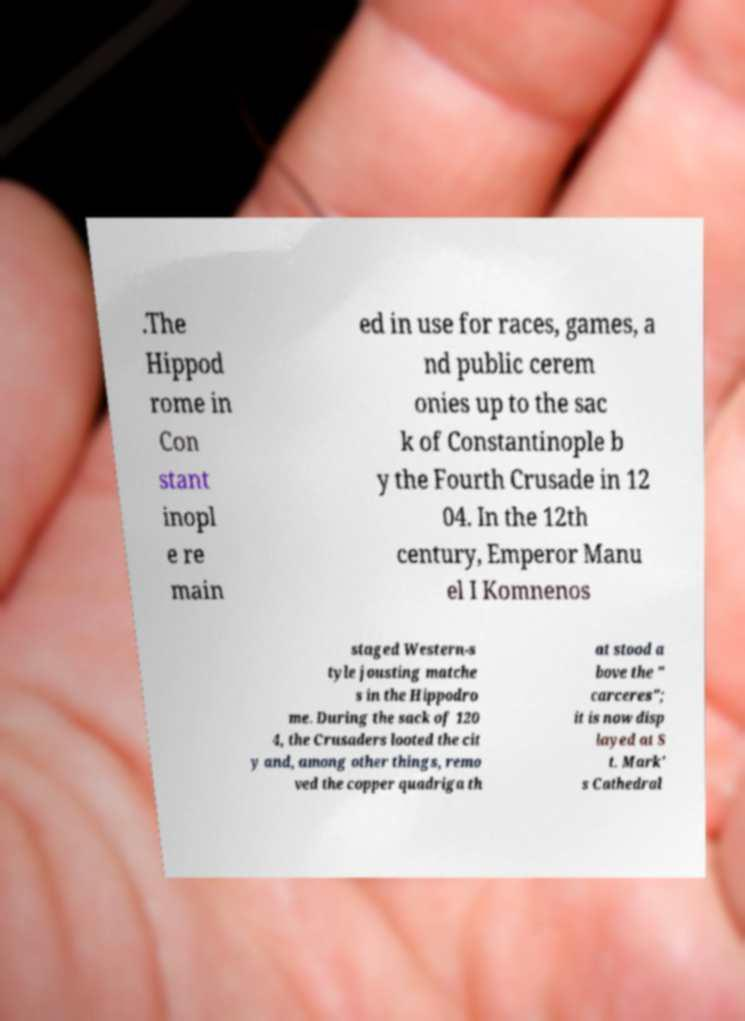Please identify and transcribe the text found in this image. .The Hippod rome in Con stant inopl e re main ed in use for races, games, a nd public cerem onies up to the sac k of Constantinople b y the Fourth Crusade in 12 04. In the 12th century, Emperor Manu el I Komnenos staged Western-s tyle jousting matche s in the Hippodro me. During the sack of 120 4, the Crusaders looted the cit y and, among other things, remo ved the copper quadriga th at stood a bove the " carceres"; it is now disp layed at S t. Mark' s Cathedral 